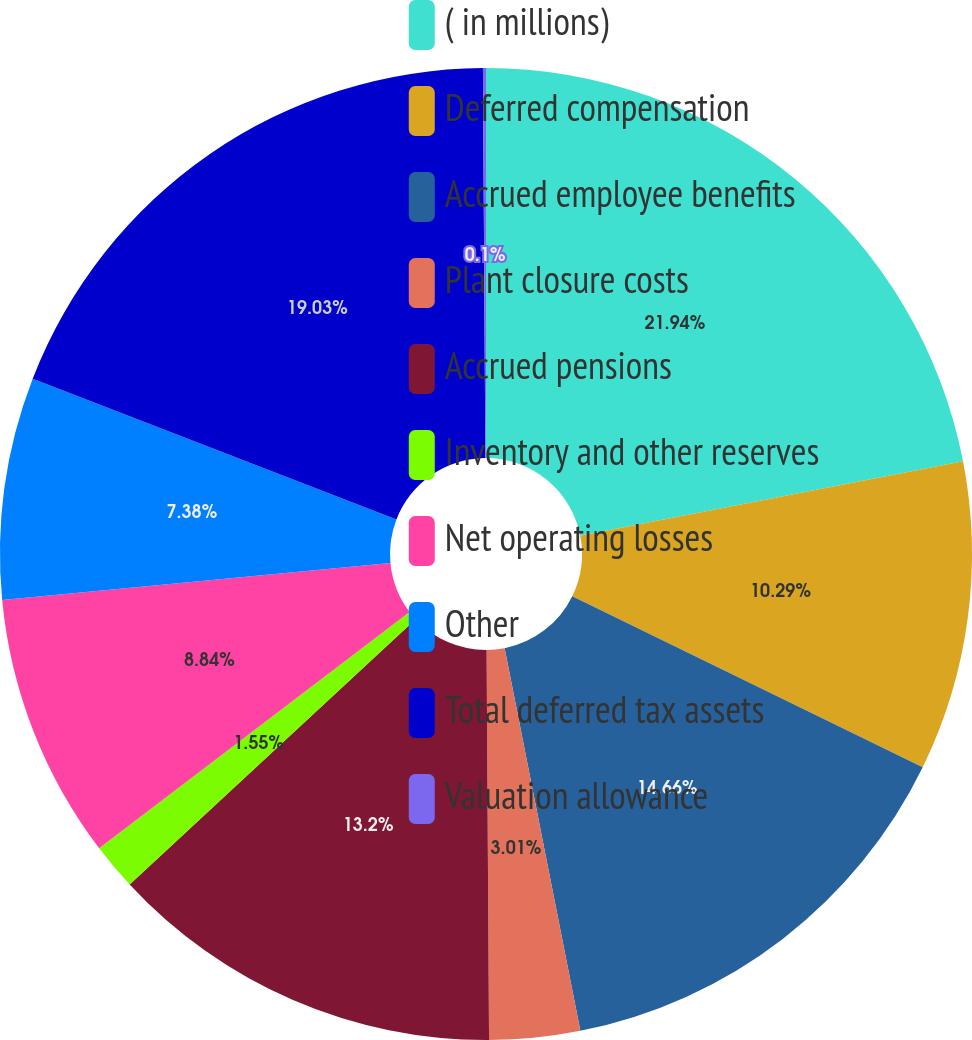Convert chart. <chart><loc_0><loc_0><loc_500><loc_500><pie_chart><fcel>( in millions)<fcel>Deferred compensation<fcel>Accrued employee benefits<fcel>Plant closure costs<fcel>Accrued pensions<fcel>Inventory and other reserves<fcel>Net operating losses<fcel>Other<fcel>Total deferred tax assets<fcel>Valuation allowance<nl><fcel>21.94%<fcel>10.29%<fcel>14.66%<fcel>3.01%<fcel>13.2%<fcel>1.55%<fcel>8.84%<fcel>7.38%<fcel>19.03%<fcel>0.1%<nl></chart> 